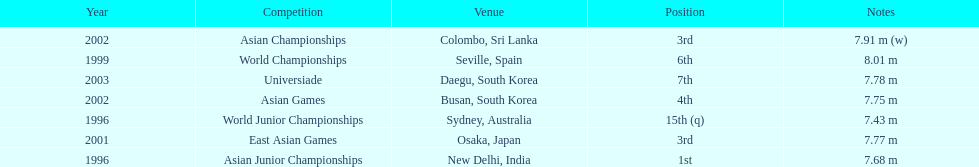How long was huang le's longest jump in 2002? 7.91 m (w). 